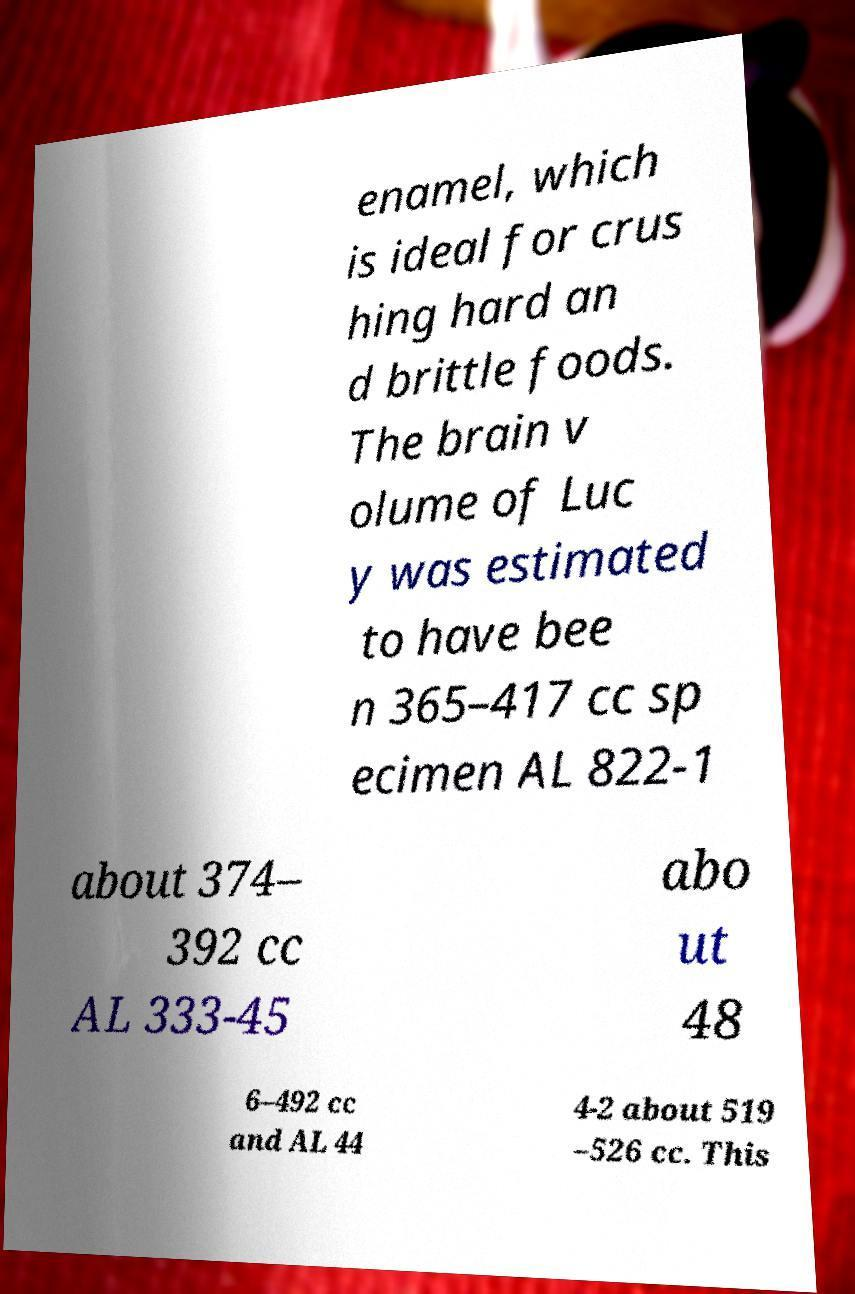Could you assist in decoding the text presented in this image and type it out clearly? enamel, which is ideal for crus hing hard an d brittle foods. The brain v olume of Luc y was estimated to have bee n 365–417 cc sp ecimen AL 822-1 about 374– 392 cc AL 333-45 abo ut 48 6–492 cc and AL 44 4-2 about 519 –526 cc. This 